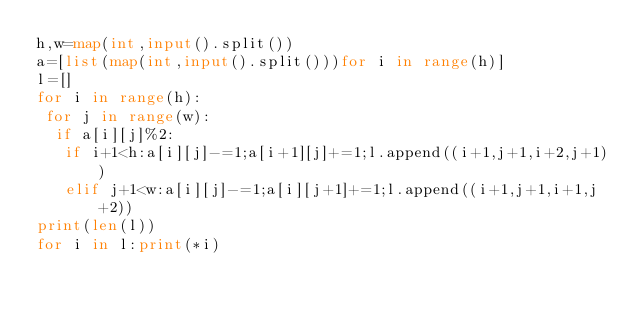<code> <loc_0><loc_0><loc_500><loc_500><_Python_>h,w=map(int,input().split())
a=[list(map(int,input().split()))for i in range(h)]
l=[]
for i in range(h):
 for j in range(w):
  if a[i][j]%2:
   if i+1<h:a[i][j]-=1;a[i+1][j]+=1;l.append((i+1,j+1,i+2,j+1))
   elif j+1<w:a[i][j]-=1;a[i][j+1]+=1;l.append((i+1,j+1,i+1,j+2))
print(len(l))
for i in l:print(*i)</code> 